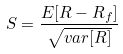<formula> <loc_0><loc_0><loc_500><loc_500>S = \frac { E [ R - R _ { f } ] } { \sqrt { v a r [ R ] } }</formula> 